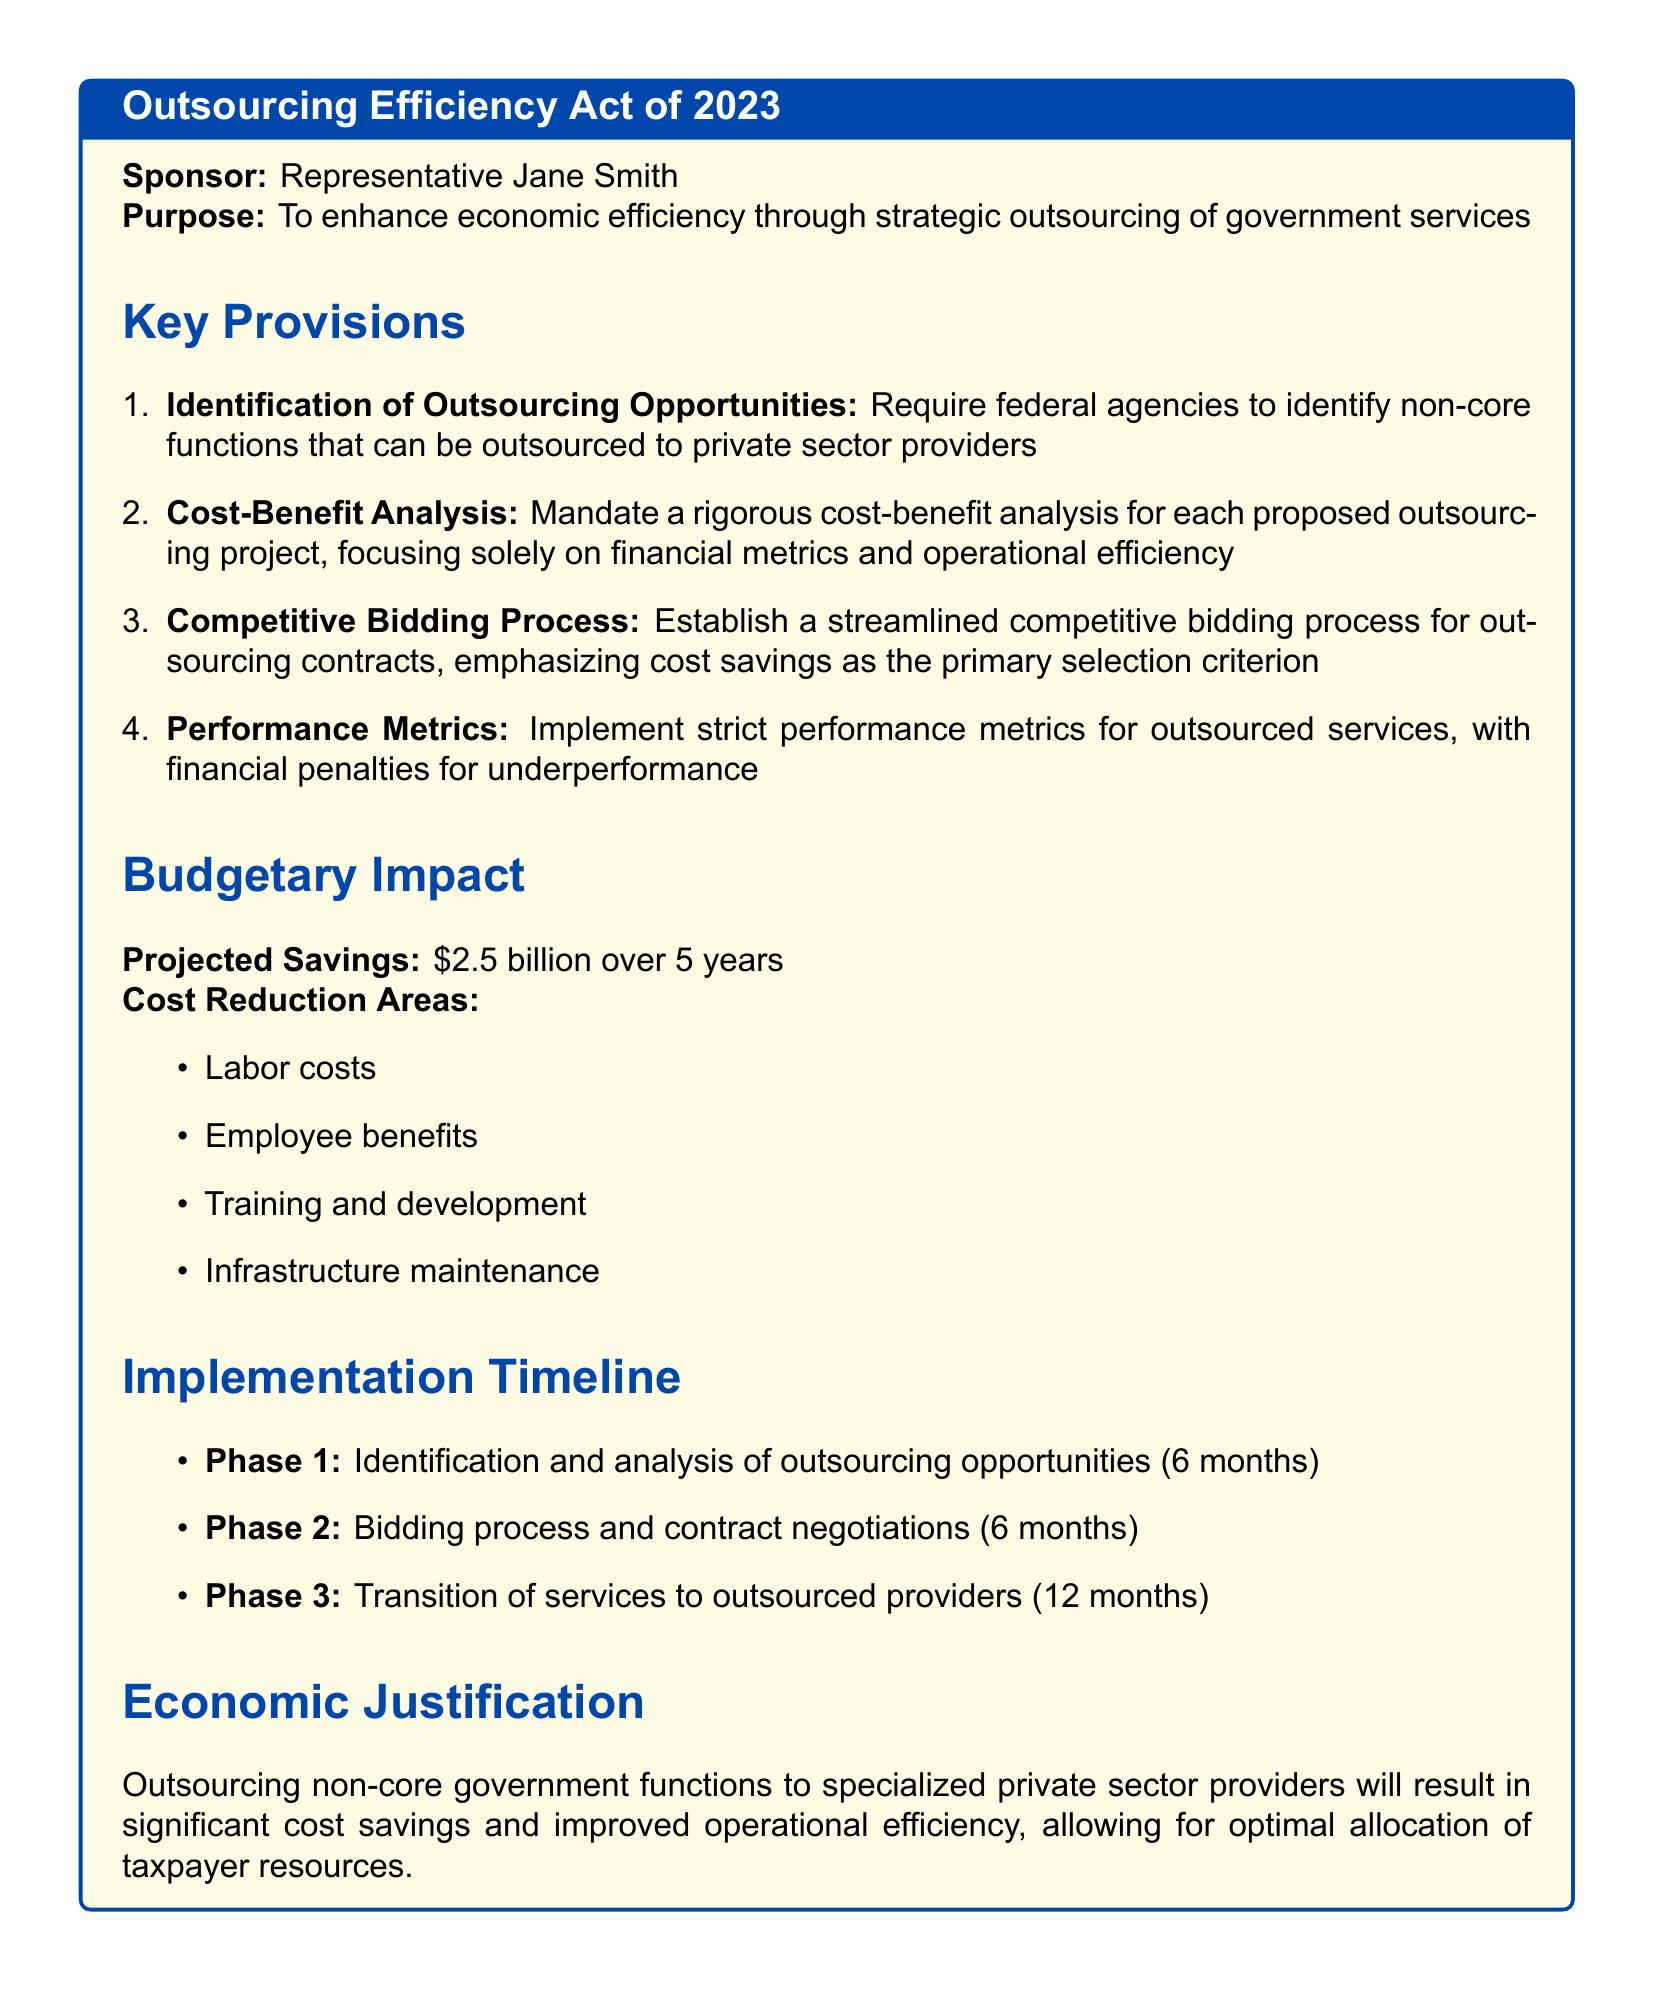What is the title of the bill? The title of the bill is stated at the beginning of the document, identifying it clearly as the "Outsourcing Efficiency Act of 2023."
Answer: Outsourcing Efficiency Act of 2023 Who sponsors the bill? The sponsor of the bill is named in the document, specifically identified as Representative Jane Smith.
Answer: Representative Jane Smith What is the projected savings over 5 years? The projected savings mentioned in the document totals to $2.5 billion over a span of five years.
Answer: $2.5 billion What area is NOT listed under cost reduction areas? The areas for cost reduction are outlined, but infrastructure improvement is not among the listed areas, indicating it is not targeted for reduction.
Answer: Infrastructure improvement How many phases are in the implementation timeline? The implementation timeline divides the process into phases, specifically detailing three distinct phases.
Answer: 3 What is the primary selection criterion for the bidding process? The document emphasizes that the primary selection criterion for outsourcing contracts is focused on achieving cost savings.
Answer: Cost savings What is a required step before transitioning services? The required step before transitioning services is the bidding process and contract negotiations that follow the identification and analysis of outsourcing opportunities.
Answer: Bidding process and contract negotiations What kind of penalties are enforced for underperforming services? The document states that there will be financial penalties imposed for services that do not meet the established performance metrics.
Answer: Financial penalties What type of functions are targeted for outsourcing? The bill specifically aims to outsource non-core functions within government services to private sector providers.
Answer: Non-core functions 